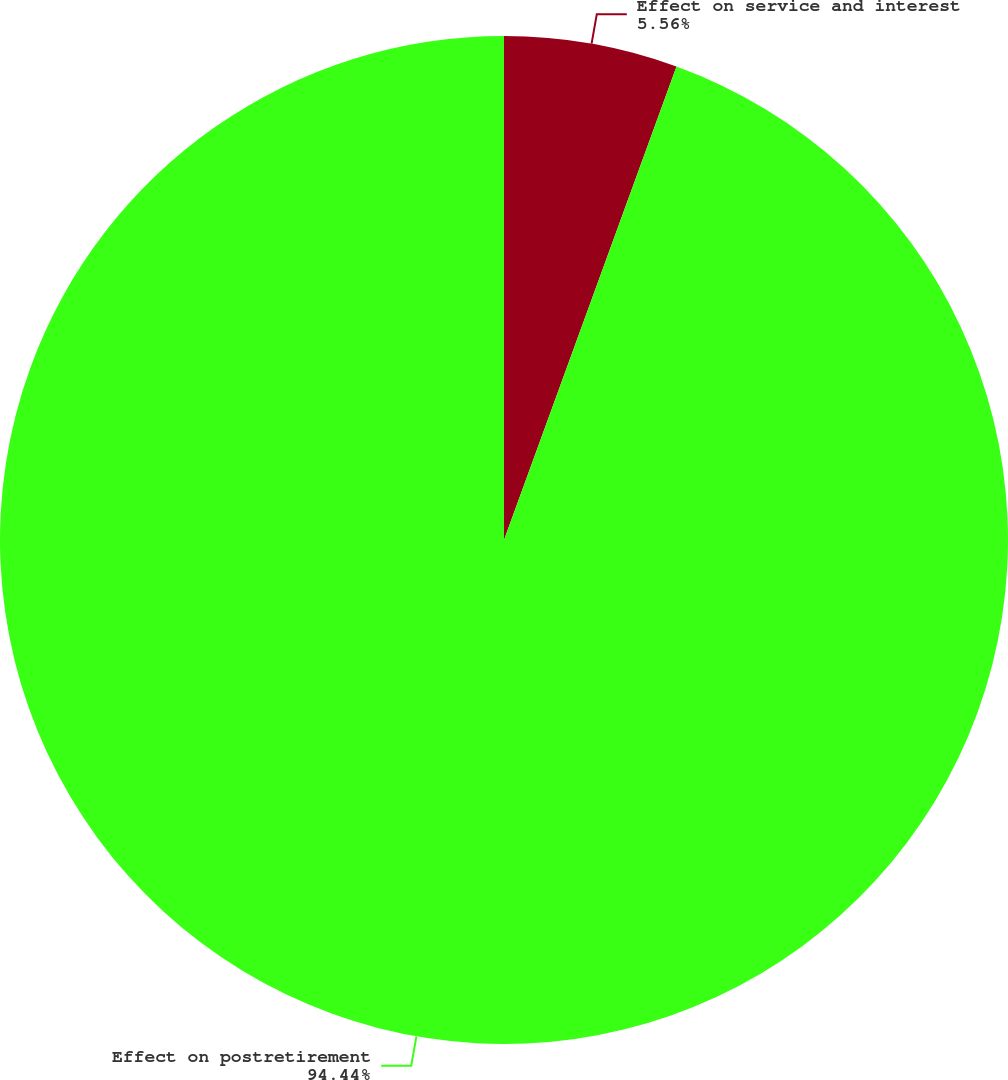Convert chart. <chart><loc_0><loc_0><loc_500><loc_500><pie_chart><fcel>Effect on service and interest<fcel>Effect on postretirement<nl><fcel>5.56%<fcel>94.44%<nl></chart> 